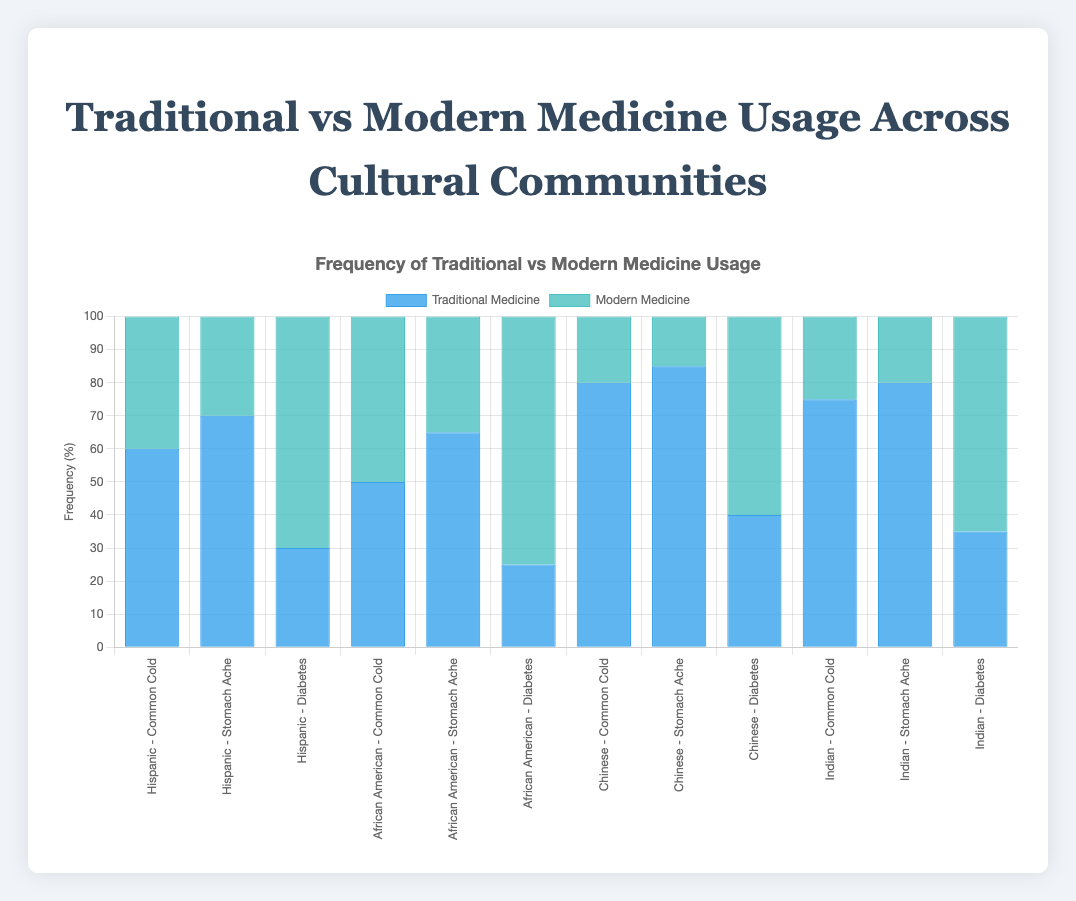Which cultural community uses traditional medicine most frequently to treat stomach aches? To find the answer, look at the bar representing traditional medicine for each community under the "Stomach Ache" ailment and compare their heights. The "Chinese" community has the tallest bar at 85%, indicating they use traditional medicine most frequently for stomach aches.
Answer: Chinese Which ailment is treated more frequently with modern medicine by the Indian community, the common cold or diabetes? Compare the bars for modern medicine frequency under the "Indian" community. The "Diabetes" bar is taller (65%) compared to the "Common Cold" bar (25%), indicating it's treated more frequently with modern medicine.
Answer: Diabetes What is the average traditional medicine frequency for the Hispanic community across all ailments? To find the average, sum the traditional medicine frequencies for the Hispanic community (60 + 70 + 30 = 160) and divide by the number of ailments (3). The average is 160/3 = 53.33%.
Answer: 53.33% Which ailment shows the smallest difference between the traditional and modern medicine usage in the African American community? Calculate the difference between traditional and modern medicine frequencies for each ailment within the African American community: Common Cold (50-50=0), Stomach Ache (65-35=30), Diabetes (25-75=50). The smallest difference is 0 for Common Cold.
Answer: Common Cold Between the Chinese and Indian communities, which has a higher traditional medicine frequency for treating the common cold? Compare the traditional medicine bars for the common cold in both communities. The Chinese community has a frequency of 80%, and the Indian community has 75%. Thus, the Chinese community has a higher traditional medicine frequency for the common cold.
Answer: Chinese Combine the modern medicine frequencies for treating diabetes across all cultural communities. Sum the modern medicine frequencies for diabetes across all communities (Hispanic 70 + African American 75 + Chinese 60 + Indian 65). Total is 270%.
Answer: 270% Does the Hispanic or African American community have a higher average traditional medicine frequency across all ailments? Calculate the average for each: Hispanic (60+70+30)/3 = 53.33%, African American (50+65+25)/3 = 46.67%. The Hispanic community has a higher average traditional medicine frequency.
Answer: Hispanic How does the usage of modern medicine for treating stomach aches differ between the Chinese and African American communities? Compare the modern medicine bars for stomach aches: Chinese (15%) and African American (35%). The African American community uses modern medicine more frequently by 20% more than the Chinese community.
Answer: 20% more Identify the ailment where traditional medicine usage is the least frequent within the Chinese community. Inspect the traditional medicine bars for the Chinese community. The lowest frequency is for diabetes at 40%.
Answer: Diabetes 